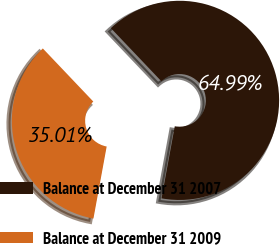Convert chart. <chart><loc_0><loc_0><loc_500><loc_500><pie_chart><fcel>Balance at December 31 2007<fcel>Balance at December 31 2009<nl><fcel>64.99%<fcel>35.01%<nl></chart> 